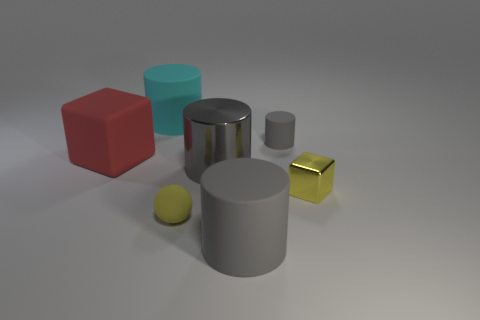The thing that is the same color as the small matte sphere is what size?
Keep it short and to the point. Small. Is the small gray rubber object the same shape as the yellow matte thing?
Your answer should be very brief. No. How many objects are either red cubes that are in front of the small gray cylinder or objects to the left of the big gray metal object?
Offer a very short reply. 3. Is there any other thing that has the same color as the ball?
Ensure brevity in your answer.  Yes. Are there an equal number of gray matte objects to the right of the large cyan matte thing and gray objects behind the yellow shiny object?
Your response must be concise. Yes. Is the number of cyan matte cylinders that are behind the matte ball greater than the number of small blue metal blocks?
Your answer should be compact. Yes. How many things are large matte cylinders in front of the shiny cube or metallic spheres?
Ensure brevity in your answer.  1. How many big gray cylinders have the same material as the yellow block?
Ensure brevity in your answer.  1. The matte thing that is the same color as the small block is what shape?
Your answer should be very brief. Sphere. Is there another tiny thing of the same shape as the red matte object?
Offer a very short reply. Yes. 